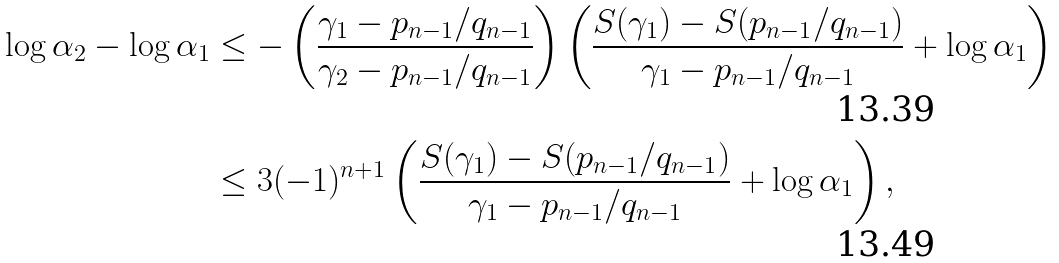Convert formula to latex. <formula><loc_0><loc_0><loc_500><loc_500>\log \alpha _ { 2 } - \log \alpha _ { 1 } & \leq - \left ( \frac { \gamma _ { 1 } - p _ { n - 1 } / q _ { n - 1 } } { \gamma _ { 2 } - p _ { n - 1 } / q _ { n - 1 } } \right ) \left ( \frac { S ( \gamma _ { 1 } ) - S ( p _ { n - 1 } / q _ { n - 1 } ) } { \gamma _ { 1 } - p _ { n - 1 } / q _ { n - 1 } } + \log \alpha _ { 1 } \right ) \\ & \leq 3 ( - 1 ) ^ { n + 1 } \left ( \frac { S ( \gamma _ { 1 } ) - S ( p _ { n - 1 } / q _ { n - 1 } ) } { \gamma _ { 1 } - p _ { n - 1 } / q _ { n - 1 } } + \log \alpha _ { 1 } \right ) ,</formula> 